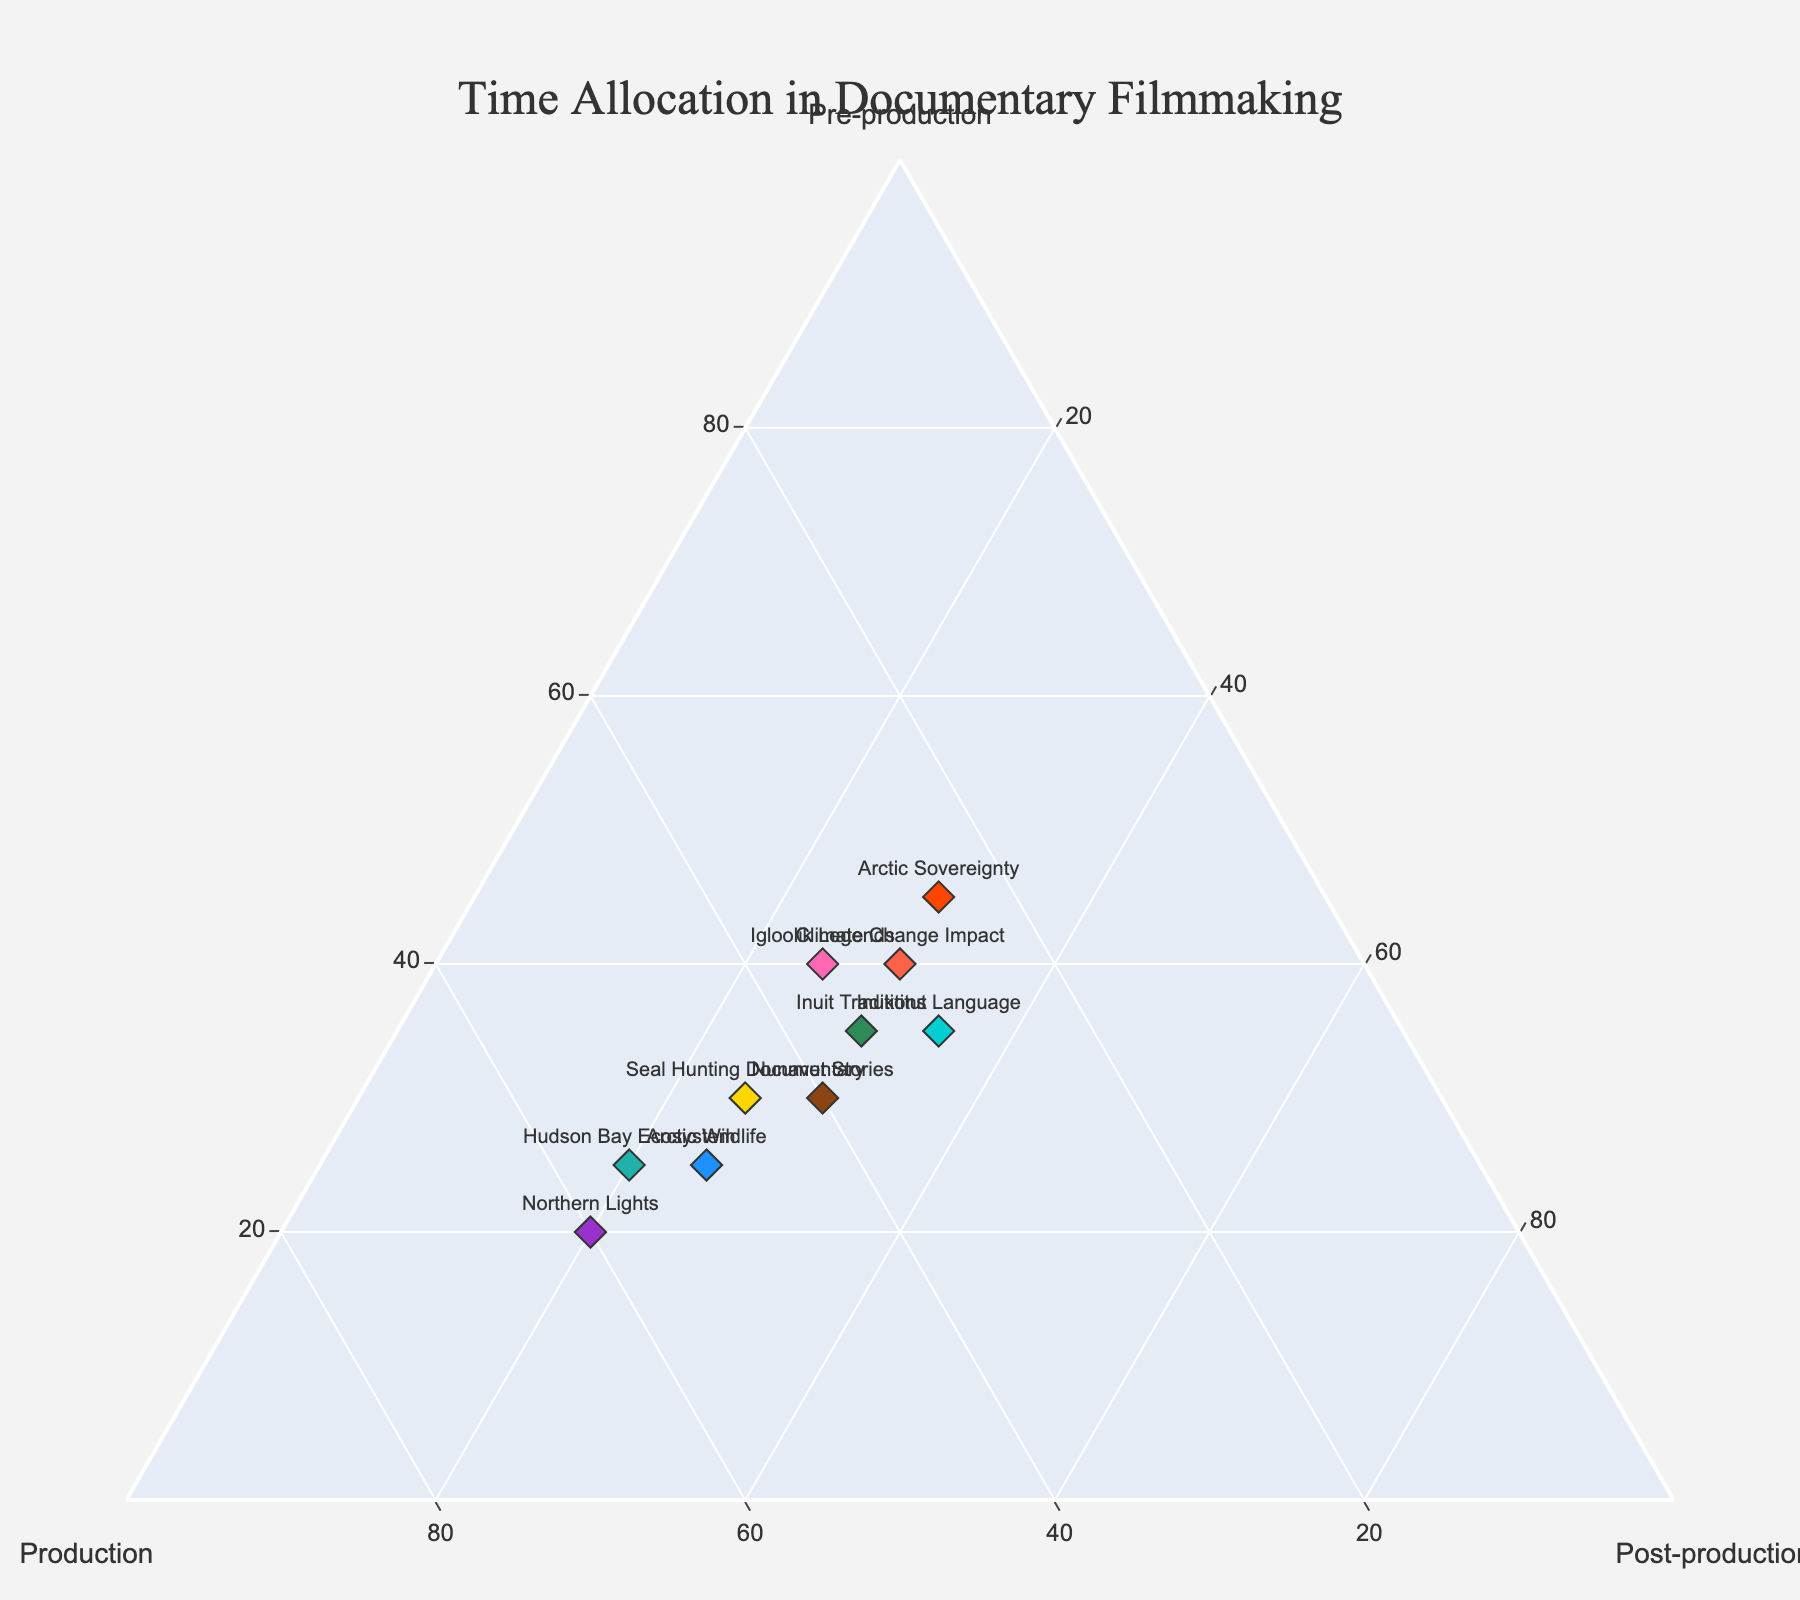Which project has the highest time allocated to Production? Look at the figure and compare the values for the Production axis. The project with the highest value on the Production axis is "Northern Lights" with 60%.
Answer: Northern Lights What is the title of the figure? Refer to the top part of the figure where the title is usually placed. The title of the figure is "Time Allocation in Documentary Filmmaking".
Answer: Time Allocation in Documentary Filmmaking What is the sum of time allocated to Pre-production and Post-production for the "Inuktitut Language" project? Add the values from the Pre-production (35%) and Post-production (35%) for the "Inuktitut Language" project. 35% + 35% = 70%.
Answer: 70% Which project has an equal time allocation for all three phases? Check the values on the Ternary Plot to find a project where Pre-production, Production, and Post-production are equal. None of the projects have equal time allocation for all three phases.
Answer: None Which project has the least time allocated to Post-production phase? Compare the values for the Post-production axis. The project with the lowest value on the Post-production axis is "Northern Lights" with 20%.
Answer: Northern Lights Are there any projects that allocate more time to Pre-production than to Production? Check the Ternary Plot for projects where the Pre-production value is greater than the Production value. The projects "Climate Change Impact", "Igloolik Legends", and "Arctic Sovereignty" allocate more time to Pre-production than to Production.
Answer: Yes Which project has a balanced time allocation between Pre-production and Post-production phases? Look for projects where Pre-production and Post-production values are equal or close. "Nunavut Stories" and "Igloolik Legends" have equal time allocation between Pre-production and Post-production (30%).
Answer: Nunavut Stories and Igloolik Legends What is the difference in Production time between "Nunavut Stories" and "Hudson Bay Ecosystem" projects? Subtract the Production value of "Nunavut Stories" (40%) from the Production value of "Hudson Bay Ecosystem" (55%). 55% - 40% = 15%.
Answer: 15% How many projects allocate exactly 30% to Pre-production? Count the number of projects in the Ternary Plot with Pre-production value equal to 30%. The projects "Nunavut Stories", "Seal Hunting Documentary", and "Inuit Traditions" allocate exactly 30% to Pre-production.
Answer: 3 Which project has the highest time allocation to Pre-production phase? Look at the Ternary Plot and identify the project with the highest value on the Pre-production axis. The project "Arctic Sovereignty" has the highest time allocation to Pre-production with 45%.
Answer: Arctic Sovereignty 